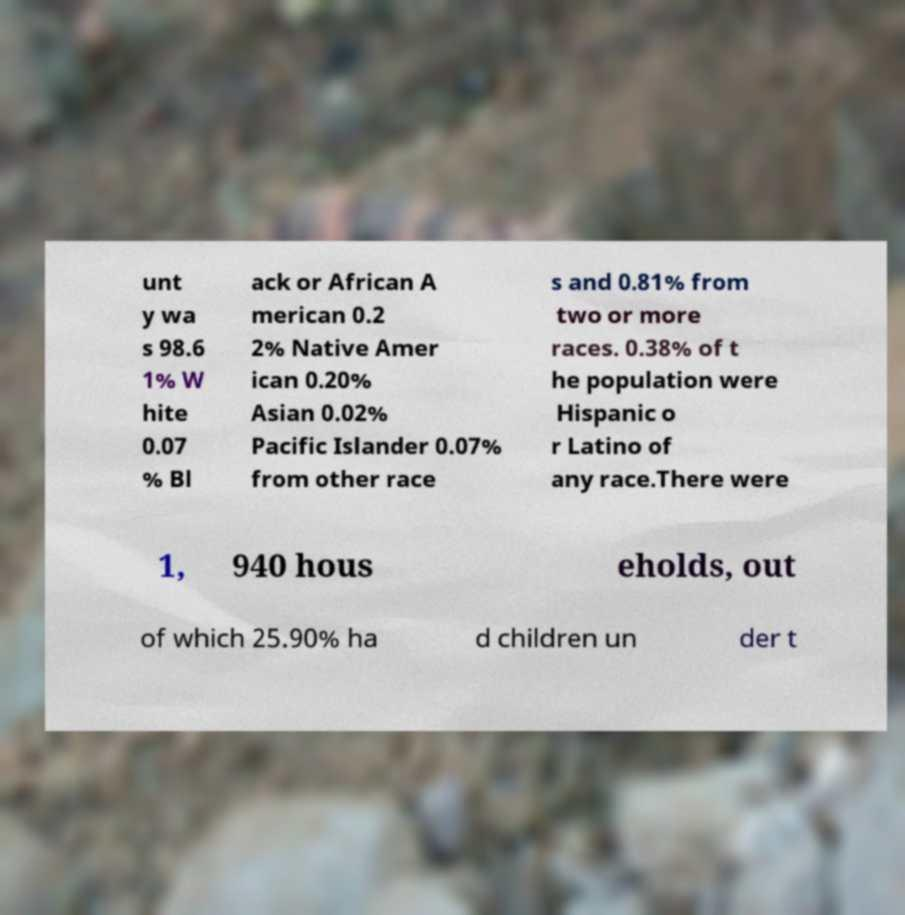Please read and relay the text visible in this image. What does it say? unt y wa s 98.6 1% W hite 0.07 % Bl ack or African A merican 0.2 2% Native Amer ican 0.20% Asian 0.02% Pacific Islander 0.07% from other race s and 0.81% from two or more races. 0.38% of t he population were Hispanic o r Latino of any race.There were 1, 940 hous eholds, out of which 25.90% ha d children un der t 